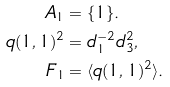Convert formula to latex. <formula><loc_0><loc_0><loc_500><loc_500>A _ { 1 } & = \{ 1 \} . \\ q ( 1 , 1 ) ^ { 2 } & = d _ { 1 } ^ { - 2 } d ^ { 2 } _ { 3 } , \\ F _ { 1 } & = \langle q ( 1 , 1 ) ^ { 2 } \rangle .</formula> 